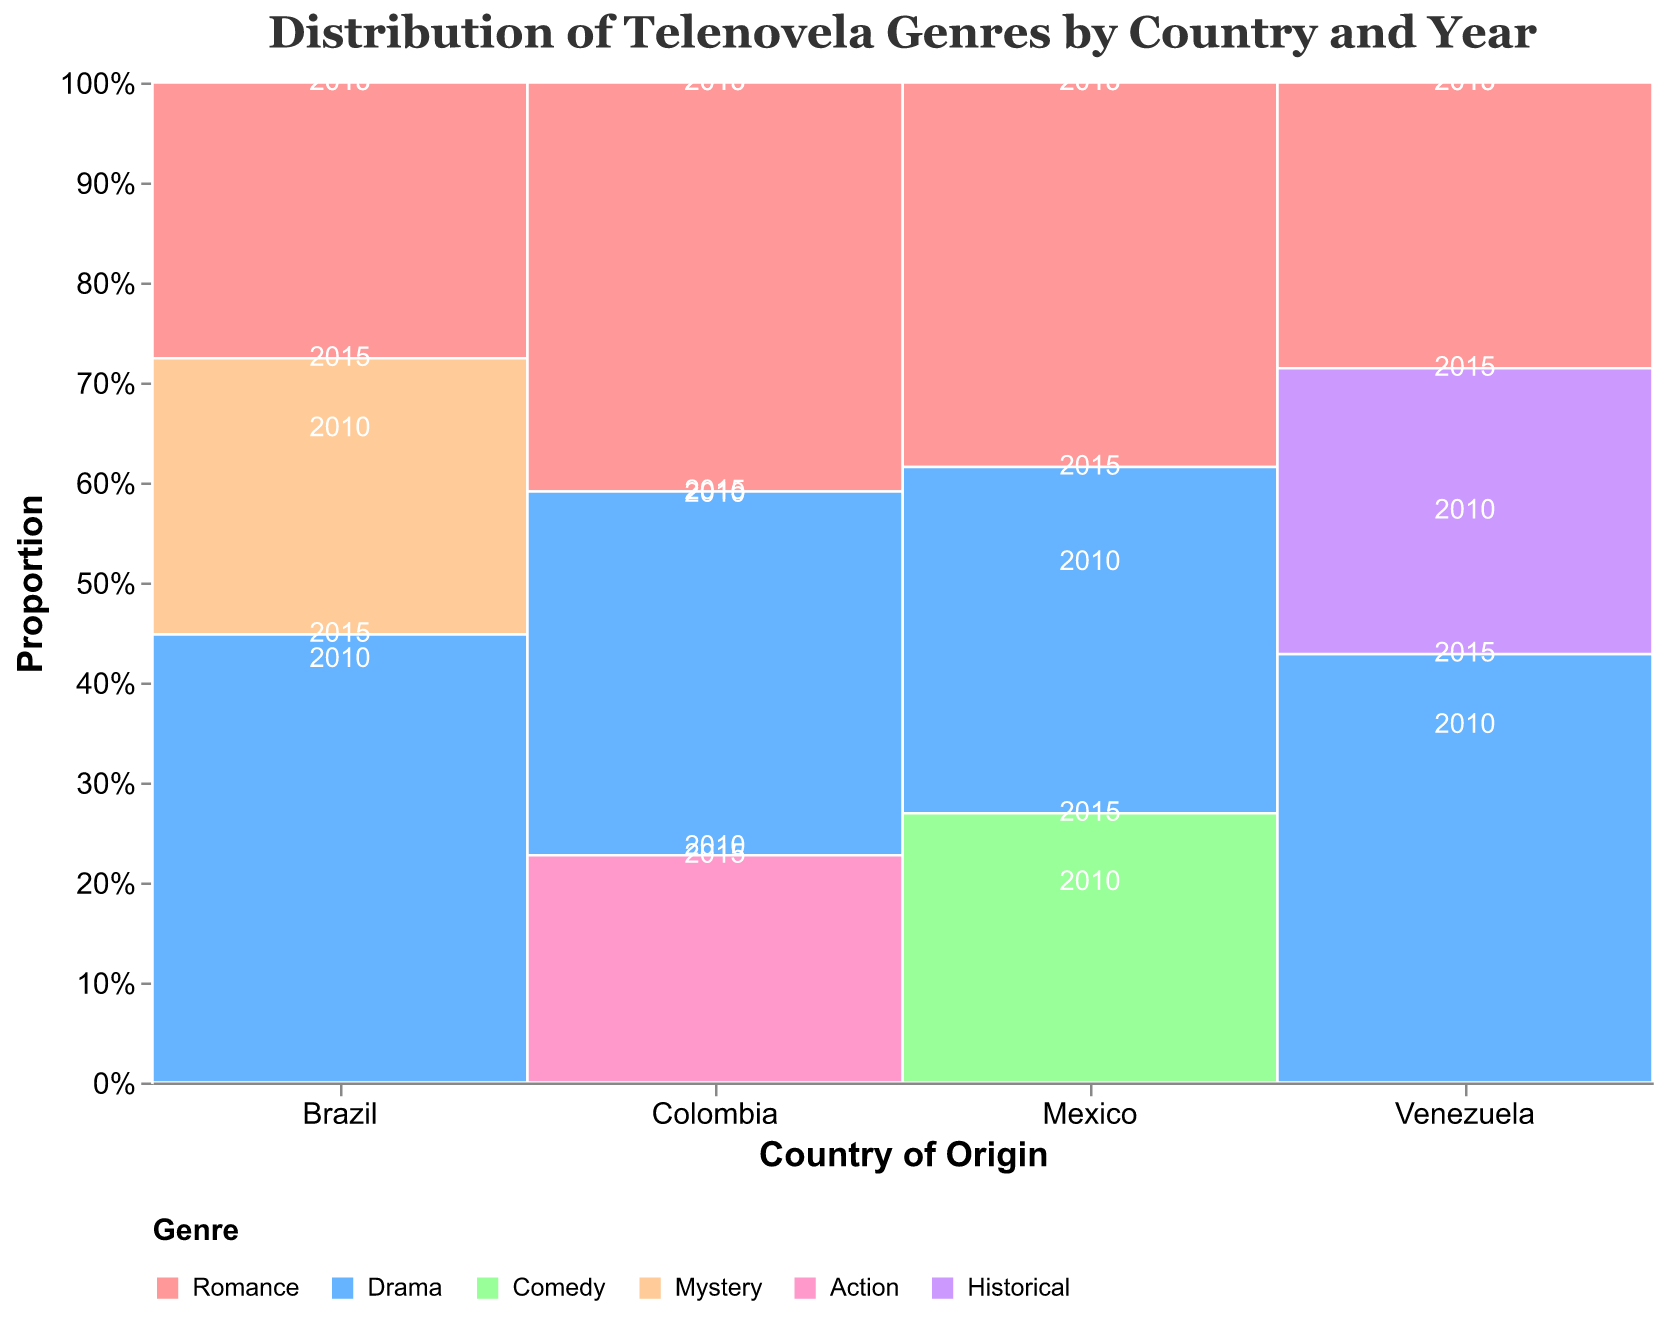What's the title of the figure? The title is displayed at the top of the figure and provides a concise description of the content being visualized. In this case, it should be read directly from the figure.
Answer: Distribution of Telenovela Genres by Country and Year What are the countries included in the mosaic plot? The countries are listed on the x-axis at the bottom of the figure. These are the categories under which the genres are divided. The countries included are Mexico, Brazil, Colombia, and Venezuela.
Answer: Mexico, Brazil, Colombia, Venezuela Which country had the highest proportion of Drama telenovelas in 2015? To determine this, we look at the heights of the Drama sections for the year 2015 across different countries. The Drama section in Brazil for 2015 is the largest.
Answer: Brazil What genre had the smallest overall count in Venezuela in 2010? We need to look at the sections within Venezuela in 2010 and identify which genre has the smallest proportion. The Historical genre in Venezuela in 2010 has the smallest count.
Answer: Historical How do the proportions of Romance telenovelas in Mexico compare between 2010 and 2015? By comparing the heights of the Romance sections for Mexico in both years, we can see that the proportion decreased slightly from 2010 to 2015.
Answer: Decreased Are there any genres that appear in Colombia but not in Venezuela for the years shown? We compare the genres represented in Colombia and Venezuela. Action appears in Colombia but not in Venezuela for both 2010 and 2015.
Answer: Action Which country produced the most Comedy telenovelas in 2015? We look at the height of the Comedy section in 2015 across all countries. Mexico has the largest proportion for Comedy in 2015.
Answer: Mexico What is the total count of Romance telenovelas produced in Brazil over the years 2010 and 2015? We add the counts of Romance telenovelas for Brazil in 2010 (9) and 2015 (8), which gives us 9 + 8 = 17.
Answer: 17 How does the distribution of genres in Mexico in 2015 compare to those in 2010? We need to compare the proportions of each genre in Mexico between the two years. In 2015, Romance decreased, Drama increased slightly, and Comedy increased compared to 2010.
Answer: Romance decreased, Drama slightly increased, Comedy increased 